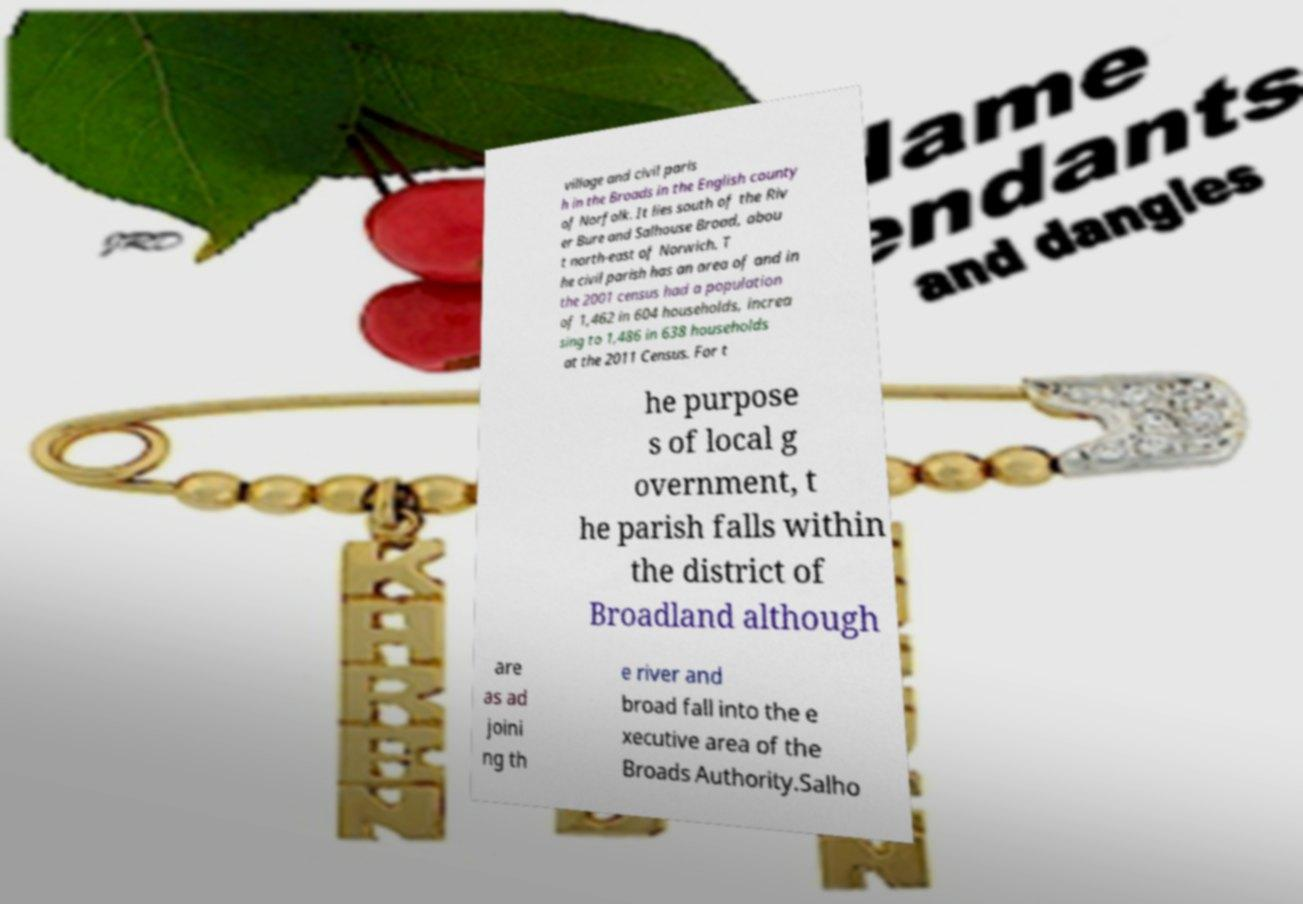I need the written content from this picture converted into text. Can you do that? village and civil paris h in the Broads in the English county of Norfolk. It lies south of the Riv er Bure and Salhouse Broad, abou t north-east of Norwich. T he civil parish has an area of and in the 2001 census had a population of 1,462 in 604 households, increa sing to 1,486 in 638 households at the 2011 Census. For t he purpose s of local g overnment, t he parish falls within the district of Broadland although are as ad joini ng th e river and broad fall into the e xecutive area of the Broads Authority.Salho 